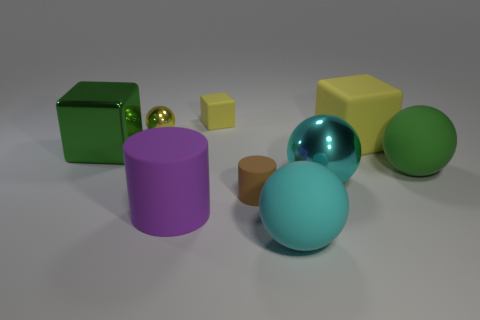Do the small metal object and the tiny matte cube have the same color?
Ensure brevity in your answer.  Yes. What is the shape of the big object that is the same color as the tiny metal ball?
Give a very brief answer. Cube. There is a tiny shiny object; does it have the same color as the block that is behind the small yellow shiny sphere?
Offer a terse response. Yes. Is the number of green objects that are on the left side of the large green ball greater than the number of small purple cylinders?
Provide a short and direct response. Yes. What number of things are either cyan balls behind the big purple rubber cylinder or large green objects left of the cyan metal thing?
Offer a terse response. 2. The yellow sphere that is the same material as the green cube is what size?
Make the answer very short. Small. Does the yellow rubber object that is right of the small yellow block have the same shape as the brown object?
Ensure brevity in your answer.  No. The rubber sphere that is the same color as the large metallic block is what size?
Your answer should be very brief. Large. How many blue things are either big metal things or cylinders?
Provide a succinct answer. 0. What number of other objects are there of the same shape as the small yellow rubber object?
Ensure brevity in your answer.  2. 